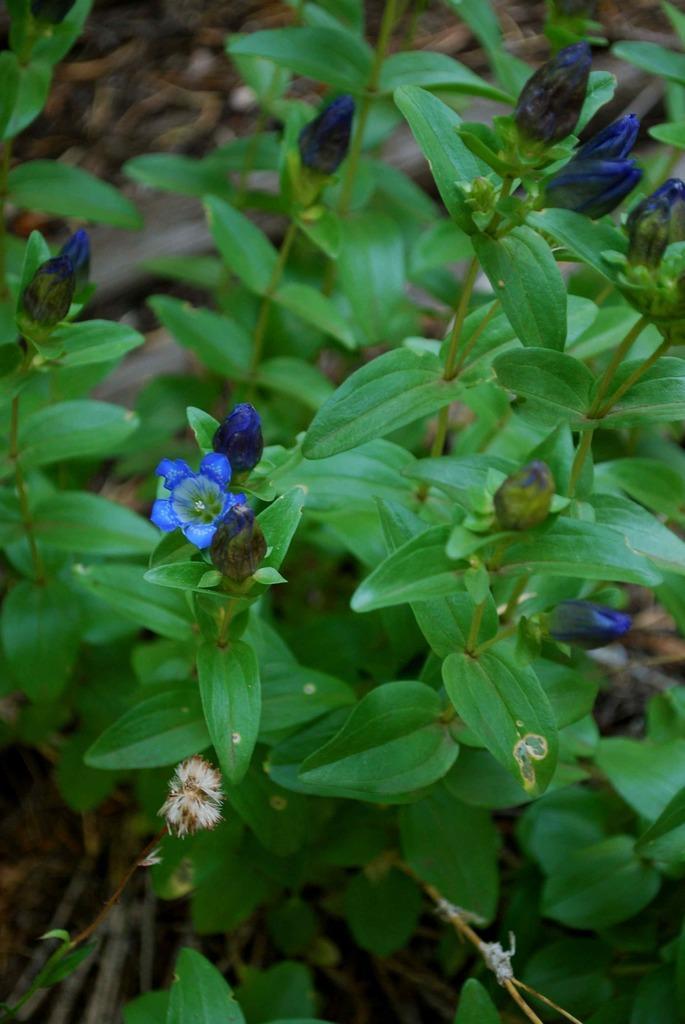Could you give a brief overview of what you see in this image? In this image, we can see a flower plant. 